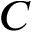<formula> <loc_0><loc_0><loc_500><loc_500>C</formula> 